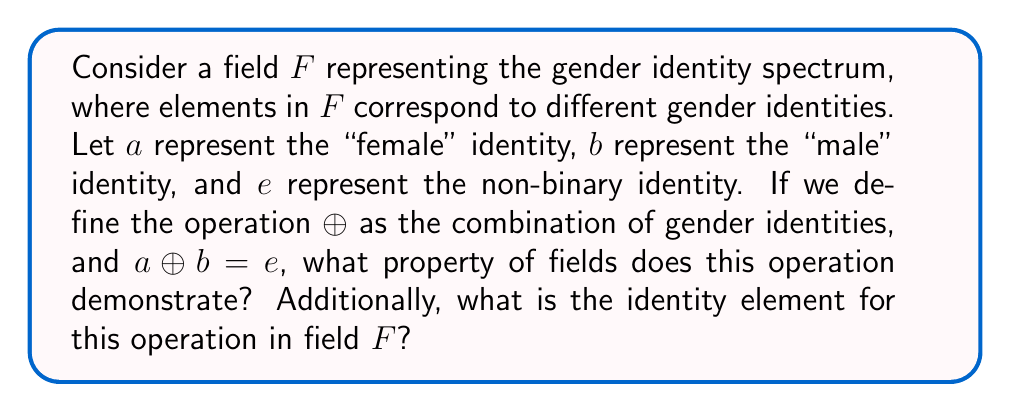What is the answer to this math problem? To answer this question, let's analyze the given information and the properties of fields:

1. In field theory, a field is a set equipped with two operations, usually called addition ($+$) and multiplication ($\cdot$), that satisfy certain axioms. In this case, we're focusing on the operation $\oplus$.

2. The question states that $a \oplus b = e$, where $a$ represents "female," $b$ represents "male," and $e$ represents non-binary.

3. In a field, for every element $x$, there exists an inverse element $-x$ such that $x + (-x) = 0$, where $0$ is the additive identity.

4. The operation $\oplus$ combining "female" and "male" to result in "non-binary" demonstrates the concept of inverse elements in field theory. This suggests that $b$ could be considered the inverse of $a$ (or vice versa) under the $\oplus$ operation.

5. The existence of inverse elements is a key property of fields. This property ensures that every equation of the form $a \oplus x = c$ has a unique solution in the field.

6. Regarding the identity element, in a field, there exists an element $i$ such that $x \oplus i = x$ for all $x$ in the field. This element would represent a gender identity that, when combined with any other identity, leaves that identity unchanged.

7. Given the context of gender identity, the identity element could be interpreted as an "agender" or "neutral" identity that doesn't affect other identities when combined.
Answer: The operation demonstrates the inverse element property. The identity element is likely an "agender" or "neutral" identity. 